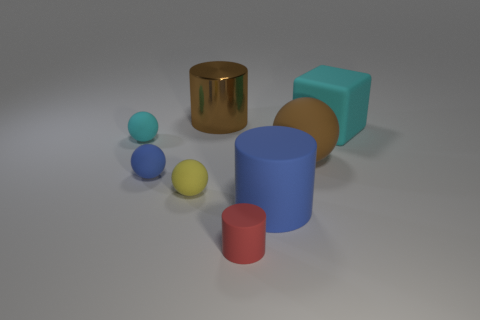There is a big cylinder that is in front of the cyan thing that is to the right of the cyan rubber object that is left of the big sphere; what is its color?
Make the answer very short. Blue. What is the material of the other tiny red object that is the same shape as the metallic object?
Make the answer very short. Rubber. How big is the cyan thing in front of the cyan object that is to the right of the large rubber sphere?
Make the answer very short. Small. What is the material of the thing that is to the right of the big rubber ball?
Ensure brevity in your answer.  Rubber. What is the size of the blue ball that is the same material as the big cyan cube?
Your response must be concise. Small. How many big shiny objects have the same shape as the yellow matte object?
Make the answer very short. 0. There is a brown matte object; is its shape the same as the matte thing behind the small cyan thing?
Ensure brevity in your answer.  No. What is the shape of the rubber object that is the same color as the shiny object?
Provide a short and direct response. Sphere. Is there a small blue ball that has the same material as the cube?
Your answer should be very brief. Yes. Is there any other thing that is the same material as the tiny yellow sphere?
Your response must be concise. Yes. 